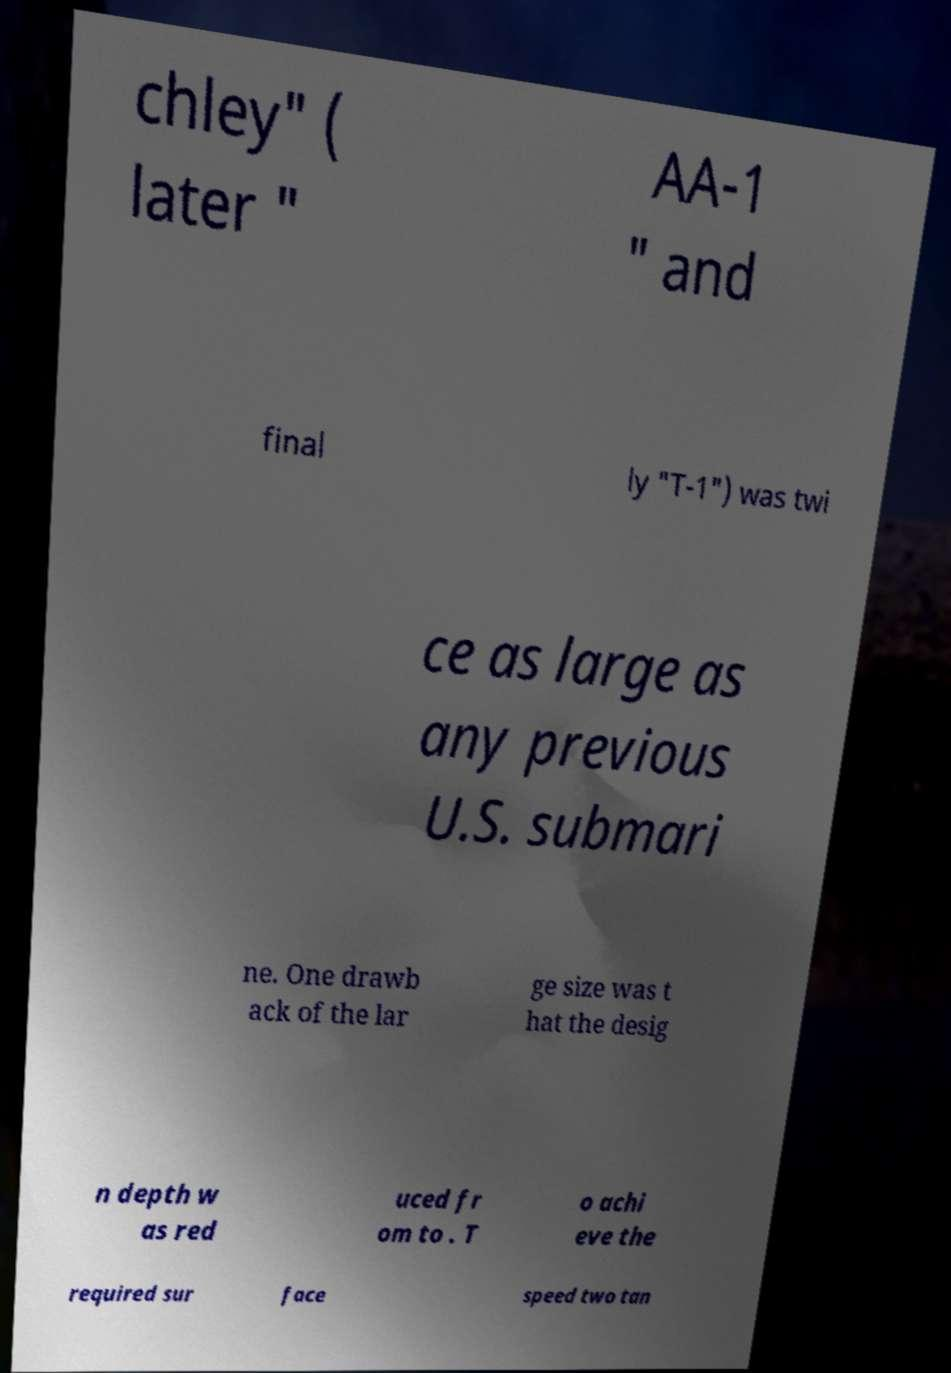Could you assist in decoding the text presented in this image and type it out clearly? chley" ( later " AA-1 " and final ly "T-1") was twi ce as large as any previous U.S. submari ne. One drawb ack of the lar ge size was t hat the desig n depth w as red uced fr om to . T o achi eve the required sur face speed two tan 